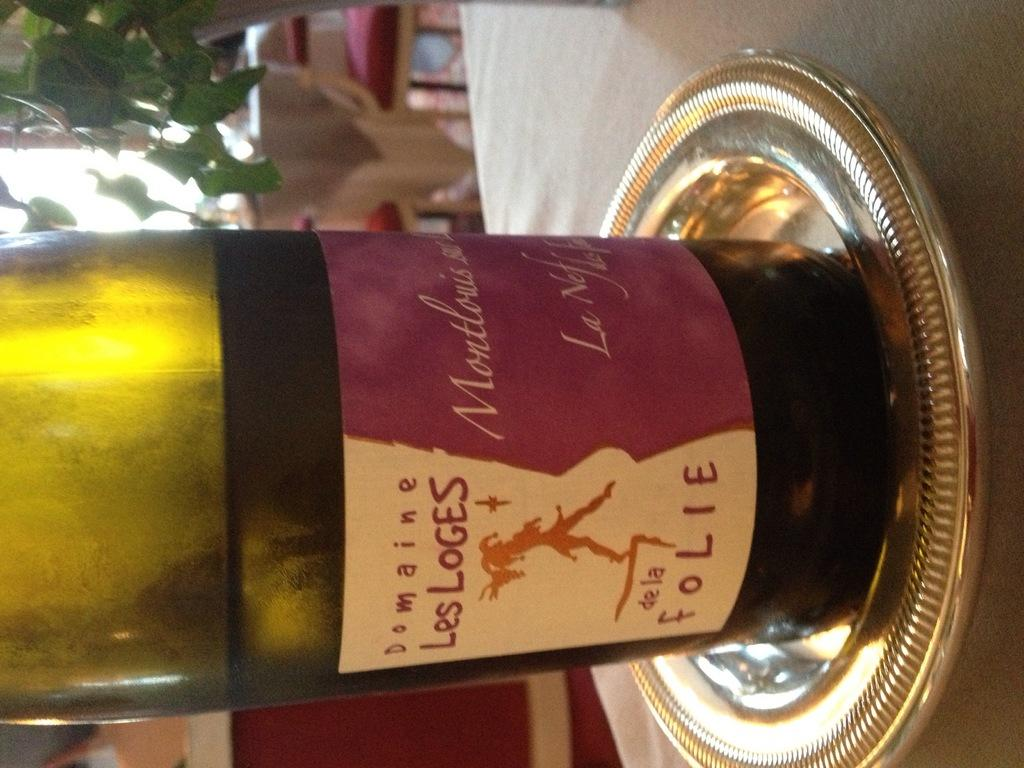<image>
Give a short and clear explanation of the subsequent image. A bottle of Les Loges wine sitting on a silver tray. 